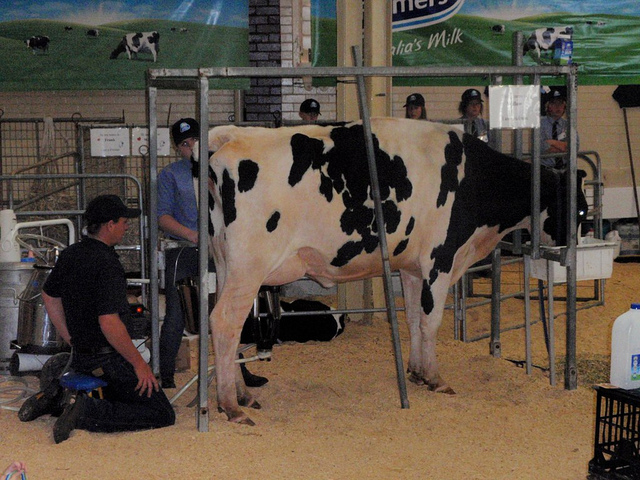<image>Why does she have a cow on her shirt? It is not known why she has a cow on her shirt. It doesn't appear to be a cow on the shirt. Why does she have a cow on her shirt? I don't know why she has a cow on her shirt. It can be for a uniform or for representation purposes. 